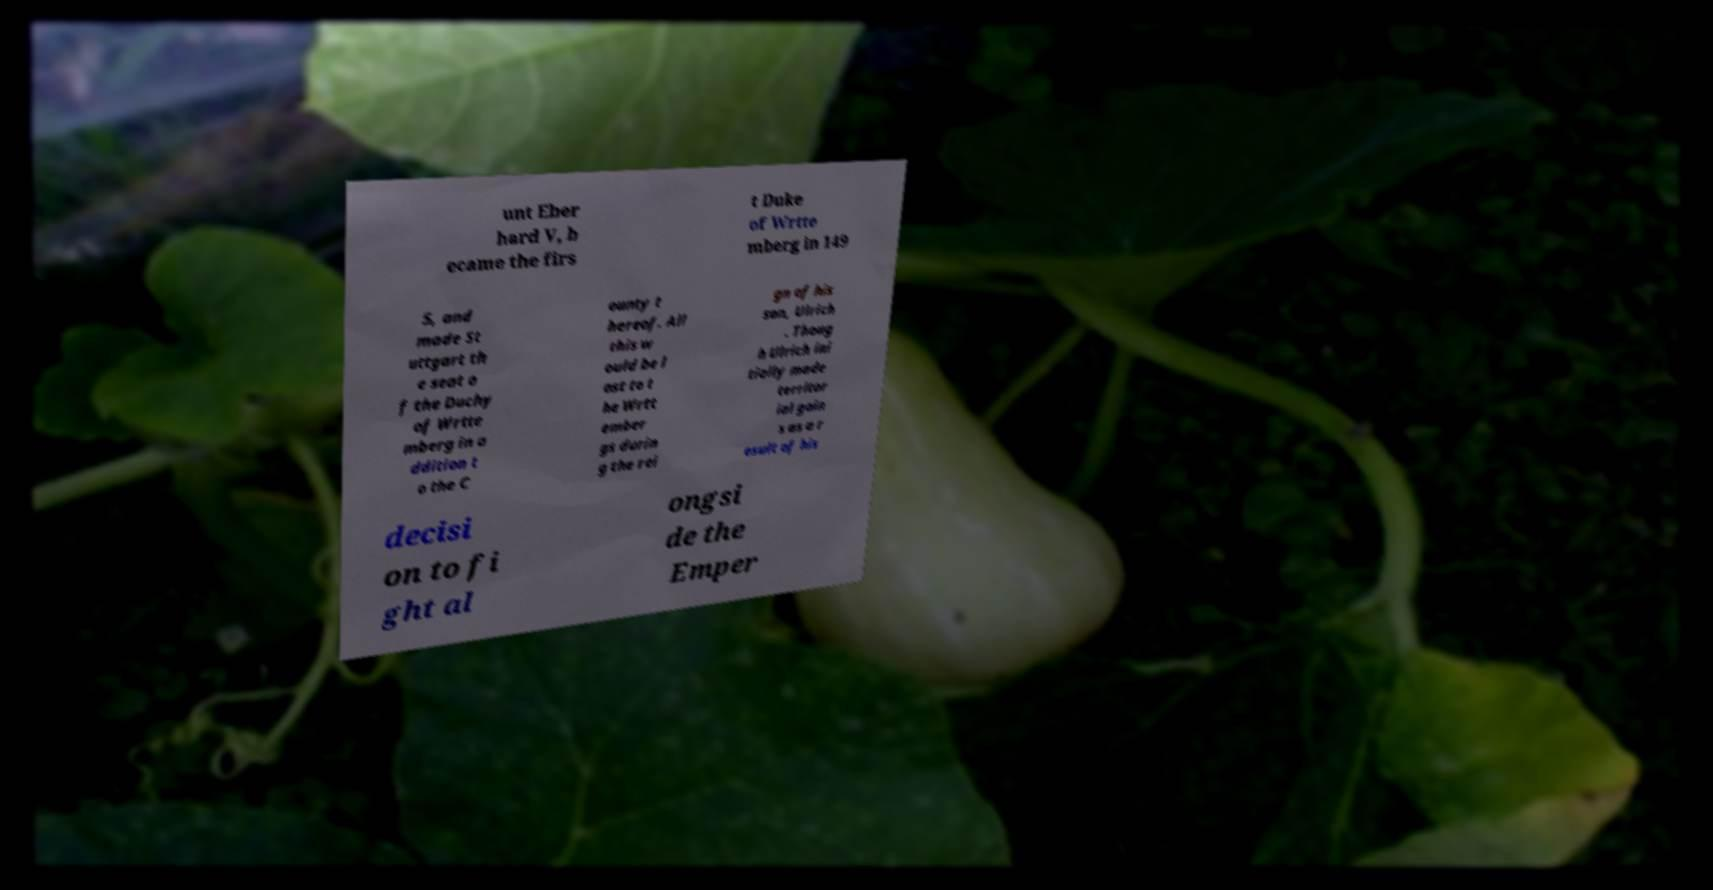Could you assist in decoding the text presented in this image and type it out clearly? unt Eber hard V, b ecame the firs t Duke of Wrtte mberg in 149 5, and made St uttgart th e seat o f the Duchy of Wrtte mberg in a ddition t o the C ounty t hereof. All this w ould be l ost to t he Wrtt ember gs durin g the rei gn of his son, Ulrich . Thoug h Ulrich ini tially made territor ial gain s as a r esult of his decisi on to fi ght al ongsi de the Emper 